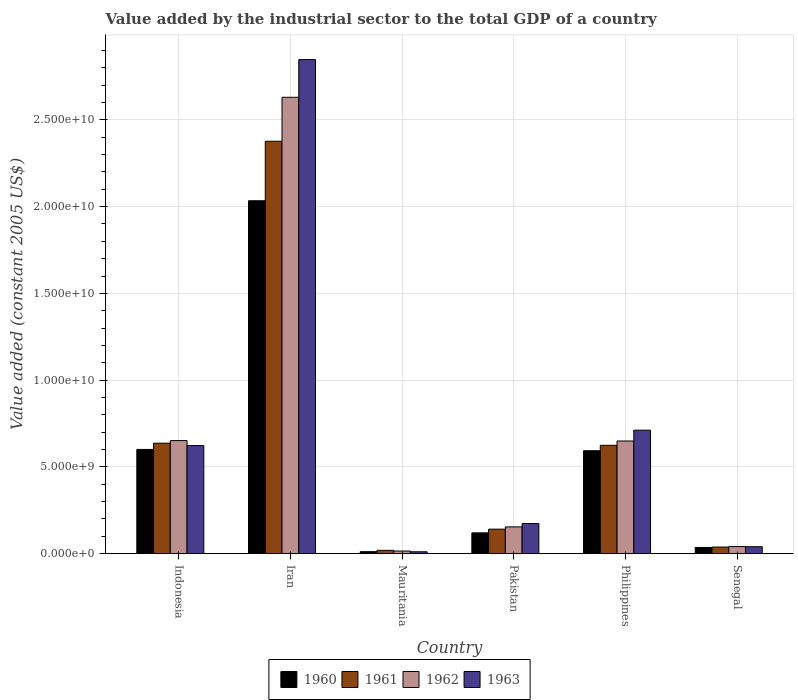How many groups of bars are there?
Provide a succinct answer. 6. How many bars are there on the 6th tick from the left?
Provide a short and direct response. 4. How many bars are there on the 1st tick from the right?
Your answer should be compact. 4. What is the label of the 1st group of bars from the left?
Offer a terse response. Indonesia. In how many cases, is the number of bars for a given country not equal to the number of legend labels?
Your answer should be very brief. 0. What is the value added by the industrial sector in 1962 in Iran?
Ensure brevity in your answer.  2.63e+1. Across all countries, what is the maximum value added by the industrial sector in 1963?
Make the answer very short. 2.85e+1. Across all countries, what is the minimum value added by the industrial sector in 1961?
Your answer should be very brief. 1.92e+08. In which country was the value added by the industrial sector in 1963 maximum?
Keep it short and to the point. Iran. In which country was the value added by the industrial sector in 1963 minimum?
Your response must be concise. Mauritania. What is the total value added by the industrial sector in 1960 in the graph?
Offer a terse response. 3.40e+1. What is the difference between the value added by the industrial sector in 1961 in Iran and that in Pakistan?
Make the answer very short. 2.24e+1. What is the difference between the value added by the industrial sector in 1963 in Iran and the value added by the industrial sector in 1961 in Indonesia?
Your answer should be very brief. 2.21e+1. What is the average value added by the industrial sector in 1963 per country?
Offer a very short reply. 7.34e+09. What is the difference between the value added by the industrial sector of/in 1963 and value added by the industrial sector of/in 1960 in Pakistan?
Ensure brevity in your answer.  5.37e+08. In how many countries, is the value added by the industrial sector in 1960 greater than 13000000000 US$?
Your response must be concise. 1. What is the ratio of the value added by the industrial sector in 1960 in Pakistan to that in Senegal?
Your answer should be very brief. 3.35. Is the value added by the industrial sector in 1961 in Mauritania less than that in Pakistan?
Give a very brief answer. Yes. What is the difference between the highest and the second highest value added by the industrial sector in 1962?
Ensure brevity in your answer.  -1.98e+1. What is the difference between the highest and the lowest value added by the industrial sector in 1962?
Provide a short and direct response. 2.62e+1. In how many countries, is the value added by the industrial sector in 1960 greater than the average value added by the industrial sector in 1960 taken over all countries?
Your answer should be compact. 3. Is the sum of the value added by the industrial sector in 1961 in Indonesia and Iran greater than the maximum value added by the industrial sector in 1960 across all countries?
Keep it short and to the point. Yes. What does the 4th bar from the left in Pakistan represents?
Your response must be concise. 1963. What does the 1st bar from the right in Iran represents?
Your answer should be very brief. 1963. Is it the case that in every country, the sum of the value added by the industrial sector in 1961 and value added by the industrial sector in 1963 is greater than the value added by the industrial sector in 1960?
Give a very brief answer. Yes. How many bars are there?
Your answer should be compact. 24. Are all the bars in the graph horizontal?
Make the answer very short. No. How many countries are there in the graph?
Your response must be concise. 6. How are the legend labels stacked?
Keep it short and to the point. Horizontal. What is the title of the graph?
Make the answer very short. Value added by the industrial sector to the total GDP of a country. Does "2015" appear as one of the legend labels in the graph?
Your response must be concise. No. What is the label or title of the Y-axis?
Offer a very short reply. Value added (constant 2005 US$). What is the Value added (constant 2005 US$) in 1960 in Indonesia?
Ensure brevity in your answer.  6.01e+09. What is the Value added (constant 2005 US$) in 1961 in Indonesia?
Offer a terse response. 6.37e+09. What is the Value added (constant 2005 US$) of 1962 in Indonesia?
Provide a succinct answer. 6.52e+09. What is the Value added (constant 2005 US$) in 1963 in Indonesia?
Provide a short and direct response. 6.23e+09. What is the Value added (constant 2005 US$) in 1960 in Iran?
Your response must be concise. 2.03e+1. What is the Value added (constant 2005 US$) of 1961 in Iran?
Your answer should be compact. 2.38e+1. What is the Value added (constant 2005 US$) in 1962 in Iran?
Provide a succinct answer. 2.63e+1. What is the Value added (constant 2005 US$) of 1963 in Iran?
Your answer should be compact. 2.85e+1. What is the Value added (constant 2005 US$) in 1960 in Mauritania?
Provide a succinct answer. 1.15e+08. What is the Value added (constant 2005 US$) in 1961 in Mauritania?
Offer a very short reply. 1.92e+08. What is the Value added (constant 2005 US$) in 1962 in Mauritania?
Ensure brevity in your answer.  1.51e+08. What is the Value added (constant 2005 US$) of 1963 in Mauritania?
Provide a short and direct response. 1.08e+08. What is the Value added (constant 2005 US$) in 1960 in Pakistan?
Your answer should be compact. 1.20e+09. What is the Value added (constant 2005 US$) in 1961 in Pakistan?
Give a very brief answer. 1.41e+09. What is the Value added (constant 2005 US$) of 1962 in Pakistan?
Give a very brief answer. 1.54e+09. What is the Value added (constant 2005 US$) in 1963 in Pakistan?
Your response must be concise. 1.74e+09. What is the Value added (constant 2005 US$) of 1960 in Philippines?
Offer a very short reply. 5.93e+09. What is the Value added (constant 2005 US$) of 1961 in Philippines?
Your answer should be very brief. 6.24e+09. What is the Value added (constant 2005 US$) in 1962 in Philippines?
Offer a terse response. 6.49e+09. What is the Value added (constant 2005 US$) of 1963 in Philippines?
Your answer should be very brief. 7.12e+09. What is the Value added (constant 2005 US$) of 1960 in Senegal?
Give a very brief answer. 3.58e+08. What is the Value added (constant 2005 US$) in 1961 in Senegal?
Give a very brief answer. 3.80e+08. What is the Value added (constant 2005 US$) of 1962 in Senegal?
Make the answer very short. 4.08e+08. What is the Value added (constant 2005 US$) in 1963 in Senegal?
Ensure brevity in your answer.  4.01e+08. Across all countries, what is the maximum Value added (constant 2005 US$) of 1960?
Make the answer very short. 2.03e+1. Across all countries, what is the maximum Value added (constant 2005 US$) of 1961?
Your answer should be compact. 2.38e+1. Across all countries, what is the maximum Value added (constant 2005 US$) of 1962?
Make the answer very short. 2.63e+1. Across all countries, what is the maximum Value added (constant 2005 US$) in 1963?
Offer a terse response. 2.85e+1. Across all countries, what is the minimum Value added (constant 2005 US$) of 1960?
Offer a terse response. 1.15e+08. Across all countries, what is the minimum Value added (constant 2005 US$) of 1961?
Provide a short and direct response. 1.92e+08. Across all countries, what is the minimum Value added (constant 2005 US$) in 1962?
Ensure brevity in your answer.  1.51e+08. Across all countries, what is the minimum Value added (constant 2005 US$) in 1963?
Your answer should be very brief. 1.08e+08. What is the total Value added (constant 2005 US$) in 1960 in the graph?
Offer a terse response. 3.40e+1. What is the total Value added (constant 2005 US$) of 1961 in the graph?
Ensure brevity in your answer.  3.84e+1. What is the total Value added (constant 2005 US$) of 1962 in the graph?
Your answer should be compact. 4.14e+1. What is the total Value added (constant 2005 US$) of 1963 in the graph?
Ensure brevity in your answer.  4.41e+1. What is the difference between the Value added (constant 2005 US$) of 1960 in Indonesia and that in Iran?
Your answer should be compact. -1.43e+1. What is the difference between the Value added (constant 2005 US$) of 1961 in Indonesia and that in Iran?
Provide a short and direct response. -1.74e+1. What is the difference between the Value added (constant 2005 US$) of 1962 in Indonesia and that in Iran?
Your answer should be very brief. -1.98e+1. What is the difference between the Value added (constant 2005 US$) of 1963 in Indonesia and that in Iran?
Your answer should be very brief. -2.22e+1. What is the difference between the Value added (constant 2005 US$) in 1960 in Indonesia and that in Mauritania?
Offer a very short reply. 5.89e+09. What is the difference between the Value added (constant 2005 US$) in 1961 in Indonesia and that in Mauritania?
Provide a short and direct response. 6.17e+09. What is the difference between the Value added (constant 2005 US$) of 1962 in Indonesia and that in Mauritania?
Your answer should be very brief. 6.37e+09. What is the difference between the Value added (constant 2005 US$) of 1963 in Indonesia and that in Mauritania?
Make the answer very short. 6.12e+09. What is the difference between the Value added (constant 2005 US$) of 1960 in Indonesia and that in Pakistan?
Keep it short and to the point. 4.81e+09. What is the difference between the Value added (constant 2005 US$) of 1961 in Indonesia and that in Pakistan?
Make the answer very short. 4.96e+09. What is the difference between the Value added (constant 2005 US$) of 1962 in Indonesia and that in Pakistan?
Offer a terse response. 4.97e+09. What is the difference between the Value added (constant 2005 US$) in 1963 in Indonesia and that in Pakistan?
Your response must be concise. 4.49e+09. What is the difference between the Value added (constant 2005 US$) of 1960 in Indonesia and that in Philippines?
Your answer should be compact. 7.44e+07. What is the difference between the Value added (constant 2005 US$) in 1961 in Indonesia and that in Philippines?
Give a very brief answer. 1.23e+08. What is the difference between the Value added (constant 2005 US$) of 1962 in Indonesia and that in Philippines?
Provide a short and direct response. 2.37e+07. What is the difference between the Value added (constant 2005 US$) of 1963 in Indonesia and that in Philippines?
Provide a short and direct response. -8.88e+08. What is the difference between the Value added (constant 2005 US$) of 1960 in Indonesia and that in Senegal?
Ensure brevity in your answer.  5.65e+09. What is the difference between the Value added (constant 2005 US$) in 1961 in Indonesia and that in Senegal?
Provide a short and direct response. 5.99e+09. What is the difference between the Value added (constant 2005 US$) in 1962 in Indonesia and that in Senegal?
Provide a succinct answer. 6.11e+09. What is the difference between the Value added (constant 2005 US$) of 1963 in Indonesia and that in Senegal?
Offer a very short reply. 5.83e+09. What is the difference between the Value added (constant 2005 US$) in 1960 in Iran and that in Mauritania?
Your response must be concise. 2.02e+1. What is the difference between the Value added (constant 2005 US$) of 1961 in Iran and that in Mauritania?
Your response must be concise. 2.36e+1. What is the difference between the Value added (constant 2005 US$) of 1962 in Iran and that in Mauritania?
Offer a terse response. 2.62e+1. What is the difference between the Value added (constant 2005 US$) in 1963 in Iran and that in Mauritania?
Provide a short and direct response. 2.84e+1. What is the difference between the Value added (constant 2005 US$) in 1960 in Iran and that in Pakistan?
Offer a very short reply. 1.91e+1. What is the difference between the Value added (constant 2005 US$) in 1961 in Iran and that in Pakistan?
Your answer should be compact. 2.24e+1. What is the difference between the Value added (constant 2005 US$) in 1962 in Iran and that in Pakistan?
Ensure brevity in your answer.  2.48e+1. What is the difference between the Value added (constant 2005 US$) in 1963 in Iran and that in Pakistan?
Make the answer very short. 2.67e+1. What is the difference between the Value added (constant 2005 US$) in 1960 in Iran and that in Philippines?
Your answer should be compact. 1.44e+1. What is the difference between the Value added (constant 2005 US$) of 1961 in Iran and that in Philippines?
Give a very brief answer. 1.75e+1. What is the difference between the Value added (constant 2005 US$) in 1962 in Iran and that in Philippines?
Provide a succinct answer. 1.98e+1. What is the difference between the Value added (constant 2005 US$) in 1963 in Iran and that in Philippines?
Your answer should be compact. 2.14e+1. What is the difference between the Value added (constant 2005 US$) of 1960 in Iran and that in Senegal?
Offer a very short reply. 2.00e+1. What is the difference between the Value added (constant 2005 US$) in 1961 in Iran and that in Senegal?
Provide a succinct answer. 2.34e+1. What is the difference between the Value added (constant 2005 US$) in 1962 in Iran and that in Senegal?
Give a very brief answer. 2.59e+1. What is the difference between the Value added (constant 2005 US$) in 1963 in Iran and that in Senegal?
Provide a succinct answer. 2.81e+1. What is the difference between the Value added (constant 2005 US$) in 1960 in Mauritania and that in Pakistan?
Your answer should be compact. -1.08e+09. What is the difference between the Value added (constant 2005 US$) in 1961 in Mauritania and that in Pakistan?
Your response must be concise. -1.22e+09. What is the difference between the Value added (constant 2005 US$) of 1962 in Mauritania and that in Pakistan?
Make the answer very short. -1.39e+09. What is the difference between the Value added (constant 2005 US$) in 1963 in Mauritania and that in Pakistan?
Offer a terse response. -1.63e+09. What is the difference between the Value added (constant 2005 US$) in 1960 in Mauritania and that in Philippines?
Your answer should be very brief. -5.82e+09. What is the difference between the Value added (constant 2005 US$) in 1961 in Mauritania and that in Philippines?
Make the answer very short. -6.05e+09. What is the difference between the Value added (constant 2005 US$) in 1962 in Mauritania and that in Philippines?
Your answer should be very brief. -6.34e+09. What is the difference between the Value added (constant 2005 US$) in 1963 in Mauritania and that in Philippines?
Offer a very short reply. -7.01e+09. What is the difference between the Value added (constant 2005 US$) of 1960 in Mauritania and that in Senegal?
Provide a succinct answer. -2.42e+08. What is the difference between the Value added (constant 2005 US$) in 1961 in Mauritania and that in Senegal?
Ensure brevity in your answer.  -1.88e+08. What is the difference between the Value added (constant 2005 US$) in 1962 in Mauritania and that in Senegal?
Make the answer very short. -2.56e+08. What is the difference between the Value added (constant 2005 US$) of 1963 in Mauritania and that in Senegal?
Offer a terse response. -2.92e+08. What is the difference between the Value added (constant 2005 US$) of 1960 in Pakistan and that in Philippines?
Make the answer very short. -4.73e+09. What is the difference between the Value added (constant 2005 US$) of 1961 in Pakistan and that in Philippines?
Provide a succinct answer. -4.83e+09. What is the difference between the Value added (constant 2005 US$) in 1962 in Pakistan and that in Philippines?
Your response must be concise. -4.95e+09. What is the difference between the Value added (constant 2005 US$) in 1963 in Pakistan and that in Philippines?
Ensure brevity in your answer.  -5.38e+09. What is the difference between the Value added (constant 2005 US$) of 1960 in Pakistan and that in Senegal?
Provide a short and direct response. 8.40e+08. What is the difference between the Value added (constant 2005 US$) of 1961 in Pakistan and that in Senegal?
Keep it short and to the point. 1.03e+09. What is the difference between the Value added (constant 2005 US$) of 1962 in Pakistan and that in Senegal?
Provide a succinct answer. 1.14e+09. What is the difference between the Value added (constant 2005 US$) in 1963 in Pakistan and that in Senegal?
Your answer should be very brief. 1.33e+09. What is the difference between the Value added (constant 2005 US$) of 1960 in Philippines and that in Senegal?
Your response must be concise. 5.57e+09. What is the difference between the Value added (constant 2005 US$) of 1961 in Philippines and that in Senegal?
Your response must be concise. 5.86e+09. What is the difference between the Value added (constant 2005 US$) of 1962 in Philippines and that in Senegal?
Keep it short and to the point. 6.09e+09. What is the difference between the Value added (constant 2005 US$) in 1963 in Philippines and that in Senegal?
Provide a short and direct response. 6.72e+09. What is the difference between the Value added (constant 2005 US$) in 1960 in Indonesia and the Value added (constant 2005 US$) in 1961 in Iran?
Your answer should be very brief. -1.78e+1. What is the difference between the Value added (constant 2005 US$) of 1960 in Indonesia and the Value added (constant 2005 US$) of 1962 in Iran?
Ensure brevity in your answer.  -2.03e+1. What is the difference between the Value added (constant 2005 US$) of 1960 in Indonesia and the Value added (constant 2005 US$) of 1963 in Iran?
Your answer should be very brief. -2.25e+1. What is the difference between the Value added (constant 2005 US$) in 1961 in Indonesia and the Value added (constant 2005 US$) in 1962 in Iran?
Give a very brief answer. -1.99e+1. What is the difference between the Value added (constant 2005 US$) of 1961 in Indonesia and the Value added (constant 2005 US$) of 1963 in Iran?
Your answer should be compact. -2.21e+1. What is the difference between the Value added (constant 2005 US$) in 1962 in Indonesia and the Value added (constant 2005 US$) in 1963 in Iran?
Offer a terse response. -2.20e+1. What is the difference between the Value added (constant 2005 US$) of 1960 in Indonesia and the Value added (constant 2005 US$) of 1961 in Mauritania?
Keep it short and to the point. 5.81e+09. What is the difference between the Value added (constant 2005 US$) of 1960 in Indonesia and the Value added (constant 2005 US$) of 1962 in Mauritania?
Offer a terse response. 5.86e+09. What is the difference between the Value added (constant 2005 US$) in 1960 in Indonesia and the Value added (constant 2005 US$) in 1963 in Mauritania?
Your response must be concise. 5.90e+09. What is the difference between the Value added (constant 2005 US$) of 1961 in Indonesia and the Value added (constant 2005 US$) of 1962 in Mauritania?
Provide a succinct answer. 6.22e+09. What is the difference between the Value added (constant 2005 US$) in 1961 in Indonesia and the Value added (constant 2005 US$) in 1963 in Mauritania?
Make the answer very short. 6.26e+09. What is the difference between the Value added (constant 2005 US$) in 1962 in Indonesia and the Value added (constant 2005 US$) in 1963 in Mauritania?
Ensure brevity in your answer.  6.41e+09. What is the difference between the Value added (constant 2005 US$) of 1960 in Indonesia and the Value added (constant 2005 US$) of 1961 in Pakistan?
Ensure brevity in your answer.  4.60e+09. What is the difference between the Value added (constant 2005 US$) of 1960 in Indonesia and the Value added (constant 2005 US$) of 1962 in Pakistan?
Your answer should be compact. 4.46e+09. What is the difference between the Value added (constant 2005 US$) of 1960 in Indonesia and the Value added (constant 2005 US$) of 1963 in Pakistan?
Keep it short and to the point. 4.27e+09. What is the difference between the Value added (constant 2005 US$) in 1961 in Indonesia and the Value added (constant 2005 US$) in 1962 in Pakistan?
Offer a terse response. 4.82e+09. What is the difference between the Value added (constant 2005 US$) in 1961 in Indonesia and the Value added (constant 2005 US$) in 1963 in Pakistan?
Offer a very short reply. 4.63e+09. What is the difference between the Value added (constant 2005 US$) in 1962 in Indonesia and the Value added (constant 2005 US$) in 1963 in Pakistan?
Make the answer very short. 4.78e+09. What is the difference between the Value added (constant 2005 US$) of 1960 in Indonesia and the Value added (constant 2005 US$) of 1961 in Philippines?
Your response must be concise. -2.37e+08. What is the difference between the Value added (constant 2005 US$) of 1960 in Indonesia and the Value added (constant 2005 US$) of 1962 in Philippines?
Your response must be concise. -4.86e+08. What is the difference between the Value added (constant 2005 US$) in 1960 in Indonesia and the Value added (constant 2005 US$) in 1963 in Philippines?
Make the answer very short. -1.11e+09. What is the difference between the Value added (constant 2005 US$) in 1961 in Indonesia and the Value added (constant 2005 US$) in 1962 in Philippines?
Give a very brief answer. -1.26e+08. What is the difference between the Value added (constant 2005 US$) of 1961 in Indonesia and the Value added (constant 2005 US$) of 1963 in Philippines?
Make the answer very short. -7.50e+08. What is the difference between the Value added (constant 2005 US$) in 1962 in Indonesia and the Value added (constant 2005 US$) in 1963 in Philippines?
Your answer should be compact. -6.01e+08. What is the difference between the Value added (constant 2005 US$) of 1960 in Indonesia and the Value added (constant 2005 US$) of 1961 in Senegal?
Provide a succinct answer. 5.63e+09. What is the difference between the Value added (constant 2005 US$) of 1960 in Indonesia and the Value added (constant 2005 US$) of 1962 in Senegal?
Provide a short and direct response. 5.60e+09. What is the difference between the Value added (constant 2005 US$) of 1960 in Indonesia and the Value added (constant 2005 US$) of 1963 in Senegal?
Keep it short and to the point. 5.61e+09. What is the difference between the Value added (constant 2005 US$) in 1961 in Indonesia and the Value added (constant 2005 US$) in 1962 in Senegal?
Give a very brief answer. 5.96e+09. What is the difference between the Value added (constant 2005 US$) of 1961 in Indonesia and the Value added (constant 2005 US$) of 1963 in Senegal?
Your response must be concise. 5.97e+09. What is the difference between the Value added (constant 2005 US$) of 1962 in Indonesia and the Value added (constant 2005 US$) of 1963 in Senegal?
Offer a terse response. 6.12e+09. What is the difference between the Value added (constant 2005 US$) of 1960 in Iran and the Value added (constant 2005 US$) of 1961 in Mauritania?
Ensure brevity in your answer.  2.01e+1. What is the difference between the Value added (constant 2005 US$) of 1960 in Iran and the Value added (constant 2005 US$) of 1962 in Mauritania?
Ensure brevity in your answer.  2.02e+1. What is the difference between the Value added (constant 2005 US$) of 1960 in Iran and the Value added (constant 2005 US$) of 1963 in Mauritania?
Your answer should be compact. 2.02e+1. What is the difference between the Value added (constant 2005 US$) in 1961 in Iran and the Value added (constant 2005 US$) in 1962 in Mauritania?
Keep it short and to the point. 2.36e+1. What is the difference between the Value added (constant 2005 US$) in 1961 in Iran and the Value added (constant 2005 US$) in 1963 in Mauritania?
Make the answer very short. 2.37e+1. What is the difference between the Value added (constant 2005 US$) of 1962 in Iran and the Value added (constant 2005 US$) of 1963 in Mauritania?
Make the answer very short. 2.62e+1. What is the difference between the Value added (constant 2005 US$) of 1960 in Iran and the Value added (constant 2005 US$) of 1961 in Pakistan?
Offer a terse response. 1.89e+1. What is the difference between the Value added (constant 2005 US$) of 1960 in Iran and the Value added (constant 2005 US$) of 1962 in Pakistan?
Offer a very short reply. 1.88e+1. What is the difference between the Value added (constant 2005 US$) of 1960 in Iran and the Value added (constant 2005 US$) of 1963 in Pakistan?
Ensure brevity in your answer.  1.86e+1. What is the difference between the Value added (constant 2005 US$) of 1961 in Iran and the Value added (constant 2005 US$) of 1962 in Pakistan?
Offer a very short reply. 2.22e+1. What is the difference between the Value added (constant 2005 US$) of 1961 in Iran and the Value added (constant 2005 US$) of 1963 in Pakistan?
Offer a very short reply. 2.20e+1. What is the difference between the Value added (constant 2005 US$) in 1962 in Iran and the Value added (constant 2005 US$) in 1963 in Pakistan?
Your response must be concise. 2.46e+1. What is the difference between the Value added (constant 2005 US$) in 1960 in Iran and the Value added (constant 2005 US$) in 1961 in Philippines?
Your answer should be very brief. 1.41e+1. What is the difference between the Value added (constant 2005 US$) of 1960 in Iran and the Value added (constant 2005 US$) of 1962 in Philippines?
Your response must be concise. 1.38e+1. What is the difference between the Value added (constant 2005 US$) in 1960 in Iran and the Value added (constant 2005 US$) in 1963 in Philippines?
Give a very brief answer. 1.32e+1. What is the difference between the Value added (constant 2005 US$) of 1961 in Iran and the Value added (constant 2005 US$) of 1962 in Philippines?
Provide a succinct answer. 1.73e+1. What is the difference between the Value added (constant 2005 US$) in 1961 in Iran and the Value added (constant 2005 US$) in 1963 in Philippines?
Make the answer very short. 1.67e+1. What is the difference between the Value added (constant 2005 US$) in 1962 in Iran and the Value added (constant 2005 US$) in 1963 in Philippines?
Offer a very short reply. 1.92e+1. What is the difference between the Value added (constant 2005 US$) of 1960 in Iran and the Value added (constant 2005 US$) of 1961 in Senegal?
Your answer should be compact. 2.00e+1. What is the difference between the Value added (constant 2005 US$) in 1960 in Iran and the Value added (constant 2005 US$) in 1962 in Senegal?
Your response must be concise. 1.99e+1. What is the difference between the Value added (constant 2005 US$) in 1960 in Iran and the Value added (constant 2005 US$) in 1963 in Senegal?
Your answer should be very brief. 1.99e+1. What is the difference between the Value added (constant 2005 US$) in 1961 in Iran and the Value added (constant 2005 US$) in 1962 in Senegal?
Give a very brief answer. 2.34e+1. What is the difference between the Value added (constant 2005 US$) of 1961 in Iran and the Value added (constant 2005 US$) of 1963 in Senegal?
Keep it short and to the point. 2.34e+1. What is the difference between the Value added (constant 2005 US$) of 1962 in Iran and the Value added (constant 2005 US$) of 1963 in Senegal?
Make the answer very short. 2.59e+1. What is the difference between the Value added (constant 2005 US$) in 1960 in Mauritania and the Value added (constant 2005 US$) in 1961 in Pakistan?
Provide a succinct answer. -1.30e+09. What is the difference between the Value added (constant 2005 US$) in 1960 in Mauritania and the Value added (constant 2005 US$) in 1962 in Pakistan?
Provide a short and direct response. -1.43e+09. What is the difference between the Value added (constant 2005 US$) of 1960 in Mauritania and the Value added (constant 2005 US$) of 1963 in Pakistan?
Keep it short and to the point. -1.62e+09. What is the difference between the Value added (constant 2005 US$) in 1961 in Mauritania and the Value added (constant 2005 US$) in 1962 in Pakistan?
Ensure brevity in your answer.  -1.35e+09. What is the difference between the Value added (constant 2005 US$) of 1961 in Mauritania and the Value added (constant 2005 US$) of 1963 in Pakistan?
Your answer should be compact. -1.54e+09. What is the difference between the Value added (constant 2005 US$) in 1962 in Mauritania and the Value added (constant 2005 US$) in 1963 in Pakistan?
Provide a short and direct response. -1.58e+09. What is the difference between the Value added (constant 2005 US$) of 1960 in Mauritania and the Value added (constant 2005 US$) of 1961 in Philippines?
Provide a succinct answer. -6.13e+09. What is the difference between the Value added (constant 2005 US$) in 1960 in Mauritania and the Value added (constant 2005 US$) in 1962 in Philippines?
Offer a very short reply. -6.38e+09. What is the difference between the Value added (constant 2005 US$) of 1960 in Mauritania and the Value added (constant 2005 US$) of 1963 in Philippines?
Offer a very short reply. -7.00e+09. What is the difference between the Value added (constant 2005 US$) in 1961 in Mauritania and the Value added (constant 2005 US$) in 1962 in Philippines?
Make the answer very short. -6.30e+09. What is the difference between the Value added (constant 2005 US$) of 1961 in Mauritania and the Value added (constant 2005 US$) of 1963 in Philippines?
Provide a succinct answer. -6.93e+09. What is the difference between the Value added (constant 2005 US$) in 1962 in Mauritania and the Value added (constant 2005 US$) in 1963 in Philippines?
Offer a terse response. -6.97e+09. What is the difference between the Value added (constant 2005 US$) of 1960 in Mauritania and the Value added (constant 2005 US$) of 1961 in Senegal?
Provide a succinct answer. -2.65e+08. What is the difference between the Value added (constant 2005 US$) of 1960 in Mauritania and the Value added (constant 2005 US$) of 1962 in Senegal?
Your response must be concise. -2.92e+08. What is the difference between the Value added (constant 2005 US$) in 1960 in Mauritania and the Value added (constant 2005 US$) in 1963 in Senegal?
Keep it short and to the point. -2.85e+08. What is the difference between the Value added (constant 2005 US$) in 1961 in Mauritania and the Value added (constant 2005 US$) in 1962 in Senegal?
Your answer should be compact. -2.15e+08. What is the difference between the Value added (constant 2005 US$) in 1961 in Mauritania and the Value added (constant 2005 US$) in 1963 in Senegal?
Provide a succinct answer. -2.08e+08. What is the difference between the Value added (constant 2005 US$) in 1962 in Mauritania and the Value added (constant 2005 US$) in 1963 in Senegal?
Your answer should be very brief. -2.49e+08. What is the difference between the Value added (constant 2005 US$) in 1960 in Pakistan and the Value added (constant 2005 US$) in 1961 in Philippines?
Offer a very short reply. -5.05e+09. What is the difference between the Value added (constant 2005 US$) of 1960 in Pakistan and the Value added (constant 2005 US$) of 1962 in Philippines?
Ensure brevity in your answer.  -5.30e+09. What is the difference between the Value added (constant 2005 US$) in 1960 in Pakistan and the Value added (constant 2005 US$) in 1963 in Philippines?
Your response must be concise. -5.92e+09. What is the difference between the Value added (constant 2005 US$) of 1961 in Pakistan and the Value added (constant 2005 US$) of 1962 in Philippines?
Offer a terse response. -5.08e+09. What is the difference between the Value added (constant 2005 US$) in 1961 in Pakistan and the Value added (constant 2005 US$) in 1963 in Philippines?
Your answer should be very brief. -5.71e+09. What is the difference between the Value added (constant 2005 US$) in 1962 in Pakistan and the Value added (constant 2005 US$) in 1963 in Philippines?
Your response must be concise. -5.57e+09. What is the difference between the Value added (constant 2005 US$) in 1960 in Pakistan and the Value added (constant 2005 US$) in 1961 in Senegal?
Your response must be concise. 8.18e+08. What is the difference between the Value added (constant 2005 US$) of 1960 in Pakistan and the Value added (constant 2005 US$) of 1962 in Senegal?
Ensure brevity in your answer.  7.91e+08. What is the difference between the Value added (constant 2005 US$) in 1960 in Pakistan and the Value added (constant 2005 US$) in 1963 in Senegal?
Your answer should be compact. 7.98e+08. What is the difference between the Value added (constant 2005 US$) of 1961 in Pakistan and the Value added (constant 2005 US$) of 1962 in Senegal?
Keep it short and to the point. 1.00e+09. What is the difference between the Value added (constant 2005 US$) in 1961 in Pakistan and the Value added (constant 2005 US$) in 1963 in Senegal?
Your answer should be compact. 1.01e+09. What is the difference between the Value added (constant 2005 US$) of 1962 in Pakistan and the Value added (constant 2005 US$) of 1963 in Senegal?
Offer a very short reply. 1.14e+09. What is the difference between the Value added (constant 2005 US$) in 1960 in Philippines and the Value added (constant 2005 US$) in 1961 in Senegal?
Your answer should be very brief. 5.55e+09. What is the difference between the Value added (constant 2005 US$) in 1960 in Philippines and the Value added (constant 2005 US$) in 1962 in Senegal?
Ensure brevity in your answer.  5.53e+09. What is the difference between the Value added (constant 2005 US$) in 1960 in Philippines and the Value added (constant 2005 US$) in 1963 in Senegal?
Offer a terse response. 5.53e+09. What is the difference between the Value added (constant 2005 US$) in 1961 in Philippines and the Value added (constant 2005 US$) in 1962 in Senegal?
Make the answer very short. 5.84e+09. What is the difference between the Value added (constant 2005 US$) in 1961 in Philippines and the Value added (constant 2005 US$) in 1963 in Senegal?
Provide a short and direct response. 5.84e+09. What is the difference between the Value added (constant 2005 US$) of 1962 in Philippines and the Value added (constant 2005 US$) of 1963 in Senegal?
Ensure brevity in your answer.  6.09e+09. What is the average Value added (constant 2005 US$) in 1960 per country?
Give a very brief answer. 5.66e+09. What is the average Value added (constant 2005 US$) in 1961 per country?
Offer a very short reply. 6.39e+09. What is the average Value added (constant 2005 US$) of 1962 per country?
Offer a terse response. 6.90e+09. What is the average Value added (constant 2005 US$) of 1963 per country?
Offer a terse response. 7.34e+09. What is the difference between the Value added (constant 2005 US$) of 1960 and Value added (constant 2005 US$) of 1961 in Indonesia?
Your answer should be compact. -3.60e+08. What is the difference between the Value added (constant 2005 US$) of 1960 and Value added (constant 2005 US$) of 1962 in Indonesia?
Ensure brevity in your answer.  -5.10e+08. What is the difference between the Value added (constant 2005 US$) in 1960 and Value added (constant 2005 US$) in 1963 in Indonesia?
Provide a succinct answer. -2.22e+08. What is the difference between the Value added (constant 2005 US$) of 1961 and Value added (constant 2005 US$) of 1962 in Indonesia?
Ensure brevity in your answer.  -1.50e+08. What is the difference between the Value added (constant 2005 US$) of 1961 and Value added (constant 2005 US$) of 1963 in Indonesia?
Offer a terse response. 1.38e+08. What is the difference between the Value added (constant 2005 US$) of 1962 and Value added (constant 2005 US$) of 1963 in Indonesia?
Give a very brief answer. 2.88e+08. What is the difference between the Value added (constant 2005 US$) in 1960 and Value added (constant 2005 US$) in 1961 in Iran?
Provide a succinct answer. -3.43e+09. What is the difference between the Value added (constant 2005 US$) of 1960 and Value added (constant 2005 US$) of 1962 in Iran?
Give a very brief answer. -5.96e+09. What is the difference between the Value added (constant 2005 US$) in 1960 and Value added (constant 2005 US$) in 1963 in Iran?
Provide a short and direct response. -8.14e+09. What is the difference between the Value added (constant 2005 US$) of 1961 and Value added (constant 2005 US$) of 1962 in Iran?
Your answer should be compact. -2.53e+09. What is the difference between the Value added (constant 2005 US$) in 1961 and Value added (constant 2005 US$) in 1963 in Iran?
Offer a very short reply. -4.71e+09. What is the difference between the Value added (constant 2005 US$) in 1962 and Value added (constant 2005 US$) in 1963 in Iran?
Give a very brief answer. -2.17e+09. What is the difference between the Value added (constant 2005 US$) of 1960 and Value added (constant 2005 US$) of 1961 in Mauritania?
Offer a very short reply. -7.68e+07. What is the difference between the Value added (constant 2005 US$) of 1960 and Value added (constant 2005 US$) of 1962 in Mauritania?
Provide a short and direct response. -3.59e+07. What is the difference between the Value added (constant 2005 US$) in 1960 and Value added (constant 2005 US$) in 1963 in Mauritania?
Offer a terse response. 7.13e+06. What is the difference between the Value added (constant 2005 US$) of 1961 and Value added (constant 2005 US$) of 1962 in Mauritania?
Offer a terse response. 4.09e+07. What is the difference between the Value added (constant 2005 US$) of 1961 and Value added (constant 2005 US$) of 1963 in Mauritania?
Your answer should be compact. 8.39e+07. What is the difference between the Value added (constant 2005 US$) of 1962 and Value added (constant 2005 US$) of 1963 in Mauritania?
Offer a very short reply. 4.31e+07. What is the difference between the Value added (constant 2005 US$) of 1960 and Value added (constant 2005 US$) of 1961 in Pakistan?
Keep it short and to the point. -2.14e+08. What is the difference between the Value added (constant 2005 US$) of 1960 and Value added (constant 2005 US$) of 1962 in Pakistan?
Your answer should be very brief. -3.45e+08. What is the difference between the Value added (constant 2005 US$) in 1960 and Value added (constant 2005 US$) in 1963 in Pakistan?
Your answer should be very brief. -5.37e+08. What is the difference between the Value added (constant 2005 US$) of 1961 and Value added (constant 2005 US$) of 1962 in Pakistan?
Make the answer very short. -1.32e+08. What is the difference between the Value added (constant 2005 US$) in 1961 and Value added (constant 2005 US$) in 1963 in Pakistan?
Offer a very short reply. -3.23e+08. What is the difference between the Value added (constant 2005 US$) of 1962 and Value added (constant 2005 US$) of 1963 in Pakistan?
Give a very brief answer. -1.92e+08. What is the difference between the Value added (constant 2005 US$) in 1960 and Value added (constant 2005 US$) in 1961 in Philippines?
Provide a short and direct response. -3.11e+08. What is the difference between the Value added (constant 2005 US$) in 1960 and Value added (constant 2005 US$) in 1962 in Philippines?
Provide a succinct answer. -5.61e+08. What is the difference between the Value added (constant 2005 US$) in 1960 and Value added (constant 2005 US$) in 1963 in Philippines?
Your response must be concise. -1.18e+09. What is the difference between the Value added (constant 2005 US$) in 1961 and Value added (constant 2005 US$) in 1962 in Philippines?
Keep it short and to the point. -2.50e+08. What is the difference between the Value added (constant 2005 US$) of 1961 and Value added (constant 2005 US$) of 1963 in Philippines?
Provide a succinct answer. -8.74e+08. What is the difference between the Value added (constant 2005 US$) in 1962 and Value added (constant 2005 US$) in 1963 in Philippines?
Your answer should be compact. -6.24e+08. What is the difference between the Value added (constant 2005 US$) of 1960 and Value added (constant 2005 US$) of 1961 in Senegal?
Keep it short and to the point. -2.25e+07. What is the difference between the Value added (constant 2005 US$) in 1960 and Value added (constant 2005 US$) in 1962 in Senegal?
Provide a succinct answer. -4.98e+07. What is the difference between the Value added (constant 2005 US$) in 1960 and Value added (constant 2005 US$) in 1963 in Senegal?
Your response must be concise. -4.27e+07. What is the difference between the Value added (constant 2005 US$) of 1961 and Value added (constant 2005 US$) of 1962 in Senegal?
Ensure brevity in your answer.  -2.72e+07. What is the difference between the Value added (constant 2005 US$) in 1961 and Value added (constant 2005 US$) in 1963 in Senegal?
Your answer should be very brief. -2.02e+07. What is the difference between the Value added (constant 2005 US$) of 1962 and Value added (constant 2005 US$) of 1963 in Senegal?
Offer a terse response. 7.03e+06. What is the ratio of the Value added (constant 2005 US$) in 1960 in Indonesia to that in Iran?
Make the answer very short. 0.3. What is the ratio of the Value added (constant 2005 US$) in 1961 in Indonesia to that in Iran?
Give a very brief answer. 0.27. What is the ratio of the Value added (constant 2005 US$) of 1962 in Indonesia to that in Iran?
Provide a short and direct response. 0.25. What is the ratio of the Value added (constant 2005 US$) of 1963 in Indonesia to that in Iran?
Provide a short and direct response. 0.22. What is the ratio of the Value added (constant 2005 US$) in 1960 in Indonesia to that in Mauritania?
Keep it short and to the point. 52.07. What is the ratio of the Value added (constant 2005 US$) in 1961 in Indonesia to that in Mauritania?
Provide a succinct answer. 33.14. What is the ratio of the Value added (constant 2005 US$) in 1962 in Indonesia to that in Mauritania?
Ensure brevity in your answer.  43.07. What is the ratio of the Value added (constant 2005 US$) of 1963 in Indonesia to that in Mauritania?
Make the answer very short. 57.56. What is the ratio of the Value added (constant 2005 US$) in 1960 in Indonesia to that in Pakistan?
Give a very brief answer. 5.01. What is the ratio of the Value added (constant 2005 US$) in 1961 in Indonesia to that in Pakistan?
Offer a terse response. 4.51. What is the ratio of the Value added (constant 2005 US$) of 1962 in Indonesia to that in Pakistan?
Offer a very short reply. 4.22. What is the ratio of the Value added (constant 2005 US$) in 1963 in Indonesia to that in Pakistan?
Offer a very short reply. 3.59. What is the ratio of the Value added (constant 2005 US$) in 1960 in Indonesia to that in Philippines?
Provide a succinct answer. 1.01. What is the ratio of the Value added (constant 2005 US$) of 1961 in Indonesia to that in Philippines?
Offer a very short reply. 1.02. What is the ratio of the Value added (constant 2005 US$) of 1962 in Indonesia to that in Philippines?
Make the answer very short. 1. What is the ratio of the Value added (constant 2005 US$) of 1963 in Indonesia to that in Philippines?
Your answer should be very brief. 0.88. What is the ratio of the Value added (constant 2005 US$) of 1960 in Indonesia to that in Senegal?
Your response must be concise. 16.79. What is the ratio of the Value added (constant 2005 US$) in 1961 in Indonesia to that in Senegal?
Give a very brief answer. 16.74. What is the ratio of the Value added (constant 2005 US$) of 1962 in Indonesia to that in Senegal?
Provide a short and direct response. 15.99. What is the ratio of the Value added (constant 2005 US$) of 1963 in Indonesia to that in Senegal?
Your response must be concise. 15.55. What is the ratio of the Value added (constant 2005 US$) in 1960 in Iran to that in Mauritania?
Provide a succinct answer. 176.32. What is the ratio of the Value added (constant 2005 US$) of 1961 in Iran to that in Mauritania?
Offer a terse response. 123.7. What is the ratio of the Value added (constant 2005 US$) in 1962 in Iran to that in Mauritania?
Offer a very short reply. 173.84. What is the ratio of the Value added (constant 2005 US$) in 1963 in Iran to that in Mauritania?
Make the answer very short. 263.11. What is the ratio of the Value added (constant 2005 US$) in 1960 in Iran to that in Pakistan?
Provide a short and direct response. 16.98. What is the ratio of the Value added (constant 2005 US$) of 1961 in Iran to that in Pakistan?
Give a very brief answer. 16.84. What is the ratio of the Value added (constant 2005 US$) of 1962 in Iran to that in Pakistan?
Keep it short and to the point. 17.04. What is the ratio of the Value added (constant 2005 US$) in 1963 in Iran to that in Pakistan?
Offer a very short reply. 16.41. What is the ratio of the Value added (constant 2005 US$) in 1960 in Iran to that in Philippines?
Your response must be concise. 3.43. What is the ratio of the Value added (constant 2005 US$) of 1961 in Iran to that in Philippines?
Your answer should be very brief. 3.81. What is the ratio of the Value added (constant 2005 US$) in 1962 in Iran to that in Philippines?
Offer a very short reply. 4.05. What is the ratio of the Value added (constant 2005 US$) in 1963 in Iran to that in Philippines?
Your answer should be very brief. 4. What is the ratio of the Value added (constant 2005 US$) in 1960 in Iran to that in Senegal?
Your answer should be very brief. 56.85. What is the ratio of the Value added (constant 2005 US$) in 1961 in Iran to that in Senegal?
Offer a terse response. 62.5. What is the ratio of the Value added (constant 2005 US$) in 1962 in Iran to that in Senegal?
Make the answer very short. 64.54. What is the ratio of the Value added (constant 2005 US$) of 1963 in Iran to that in Senegal?
Make the answer very short. 71.1. What is the ratio of the Value added (constant 2005 US$) of 1960 in Mauritania to that in Pakistan?
Your response must be concise. 0.1. What is the ratio of the Value added (constant 2005 US$) of 1961 in Mauritania to that in Pakistan?
Offer a terse response. 0.14. What is the ratio of the Value added (constant 2005 US$) of 1962 in Mauritania to that in Pakistan?
Your answer should be very brief. 0.1. What is the ratio of the Value added (constant 2005 US$) of 1963 in Mauritania to that in Pakistan?
Keep it short and to the point. 0.06. What is the ratio of the Value added (constant 2005 US$) of 1960 in Mauritania to that in Philippines?
Offer a terse response. 0.02. What is the ratio of the Value added (constant 2005 US$) of 1961 in Mauritania to that in Philippines?
Provide a short and direct response. 0.03. What is the ratio of the Value added (constant 2005 US$) of 1962 in Mauritania to that in Philippines?
Offer a terse response. 0.02. What is the ratio of the Value added (constant 2005 US$) in 1963 in Mauritania to that in Philippines?
Provide a short and direct response. 0.02. What is the ratio of the Value added (constant 2005 US$) in 1960 in Mauritania to that in Senegal?
Offer a terse response. 0.32. What is the ratio of the Value added (constant 2005 US$) of 1961 in Mauritania to that in Senegal?
Give a very brief answer. 0.51. What is the ratio of the Value added (constant 2005 US$) of 1962 in Mauritania to that in Senegal?
Your response must be concise. 0.37. What is the ratio of the Value added (constant 2005 US$) of 1963 in Mauritania to that in Senegal?
Your answer should be compact. 0.27. What is the ratio of the Value added (constant 2005 US$) of 1960 in Pakistan to that in Philippines?
Offer a very short reply. 0.2. What is the ratio of the Value added (constant 2005 US$) in 1961 in Pakistan to that in Philippines?
Give a very brief answer. 0.23. What is the ratio of the Value added (constant 2005 US$) of 1962 in Pakistan to that in Philippines?
Make the answer very short. 0.24. What is the ratio of the Value added (constant 2005 US$) of 1963 in Pakistan to that in Philippines?
Keep it short and to the point. 0.24. What is the ratio of the Value added (constant 2005 US$) of 1960 in Pakistan to that in Senegal?
Your answer should be compact. 3.35. What is the ratio of the Value added (constant 2005 US$) in 1961 in Pakistan to that in Senegal?
Offer a very short reply. 3.71. What is the ratio of the Value added (constant 2005 US$) in 1962 in Pakistan to that in Senegal?
Make the answer very short. 3.79. What is the ratio of the Value added (constant 2005 US$) of 1963 in Pakistan to that in Senegal?
Ensure brevity in your answer.  4.33. What is the ratio of the Value added (constant 2005 US$) of 1960 in Philippines to that in Senegal?
Provide a short and direct response. 16.58. What is the ratio of the Value added (constant 2005 US$) of 1961 in Philippines to that in Senegal?
Keep it short and to the point. 16.42. What is the ratio of the Value added (constant 2005 US$) in 1962 in Philippines to that in Senegal?
Offer a very short reply. 15.93. What is the ratio of the Value added (constant 2005 US$) of 1963 in Philippines to that in Senegal?
Your answer should be compact. 17.77. What is the difference between the highest and the second highest Value added (constant 2005 US$) in 1960?
Ensure brevity in your answer.  1.43e+1. What is the difference between the highest and the second highest Value added (constant 2005 US$) in 1961?
Offer a very short reply. 1.74e+1. What is the difference between the highest and the second highest Value added (constant 2005 US$) in 1962?
Your response must be concise. 1.98e+1. What is the difference between the highest and the second highest Value added (constant 2005 US$) in 1963?
Offer a very short reply. 2.14e+1. What is the difference between the highest and the lowest Value added (constant 2005 US$) of 1960?
Provide a succinct answer. 2.02e+1. What is the difference between the highest and the lowest Value added (constant 2005 US$) in 1961?
Provide a succinct answer. 2.36e+1. What is the difference between the highest and the lowest Value added (constant 2005 US$) of 1962?
Offer a terse response. 2.62e+1. What is the difference between the highest and the lowest Value added (constant 2005 US$) of 1963?
Keep it short and to the point. 2.84e+1. 